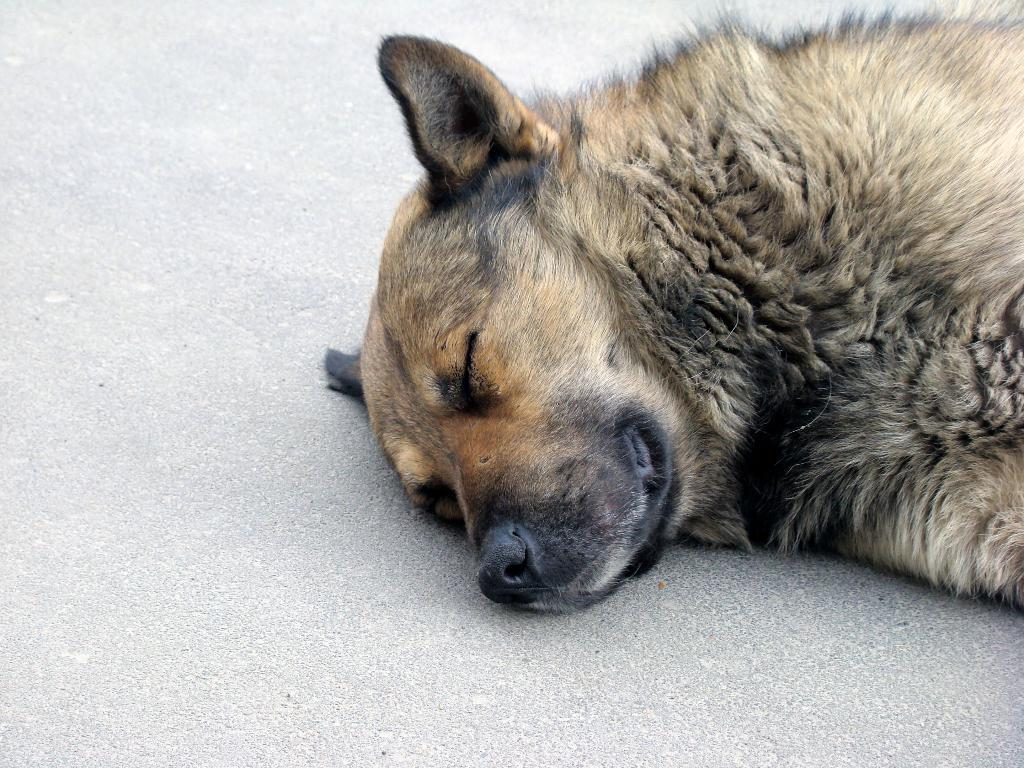What type of animal is present in the image? There is a dog in the image. What is the dog doing in the image? The dog is lying on the ground. What type of vessel is the dog using to sail across the ocean in the image? There is no vessel present in the image, and the dog is not sailing across the ocean. 